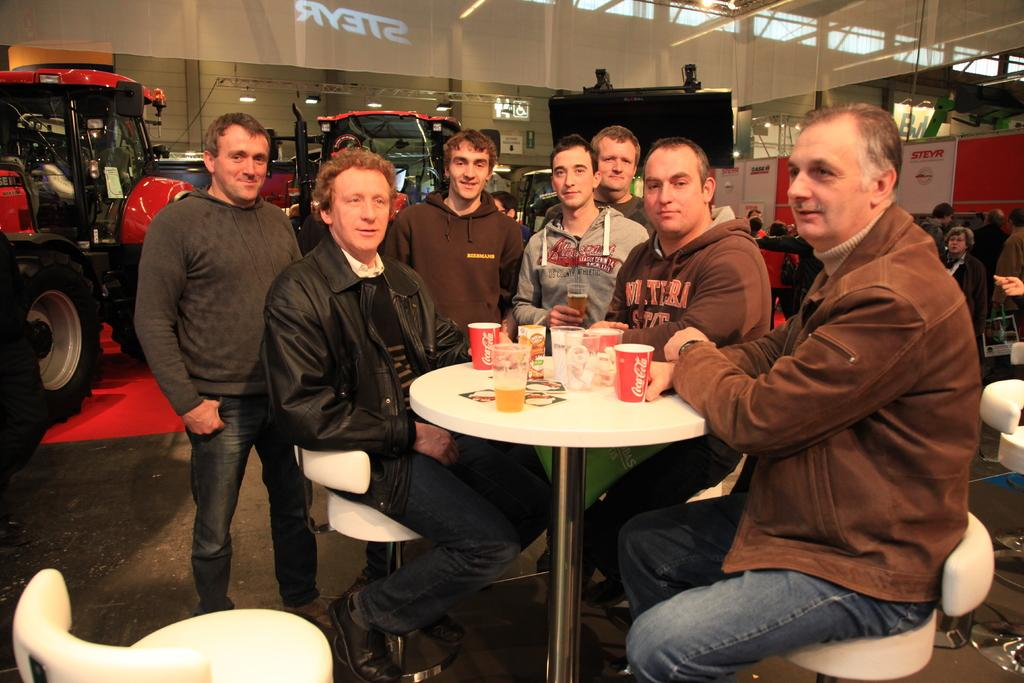What are the people in the image doing? The people in the image are sitting on chairs. What objects can be seen in the image that might be used for drinking? There are glasses in the image. What type of transportation is visible in the image? There are vehicles in the image. What type of pump can be seen in the image? There is no pump present in the image. 